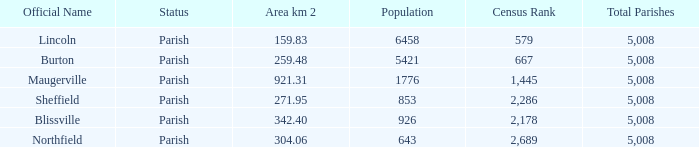What are the official name(s) of places with an area of 304.06 km2? Northfield. 